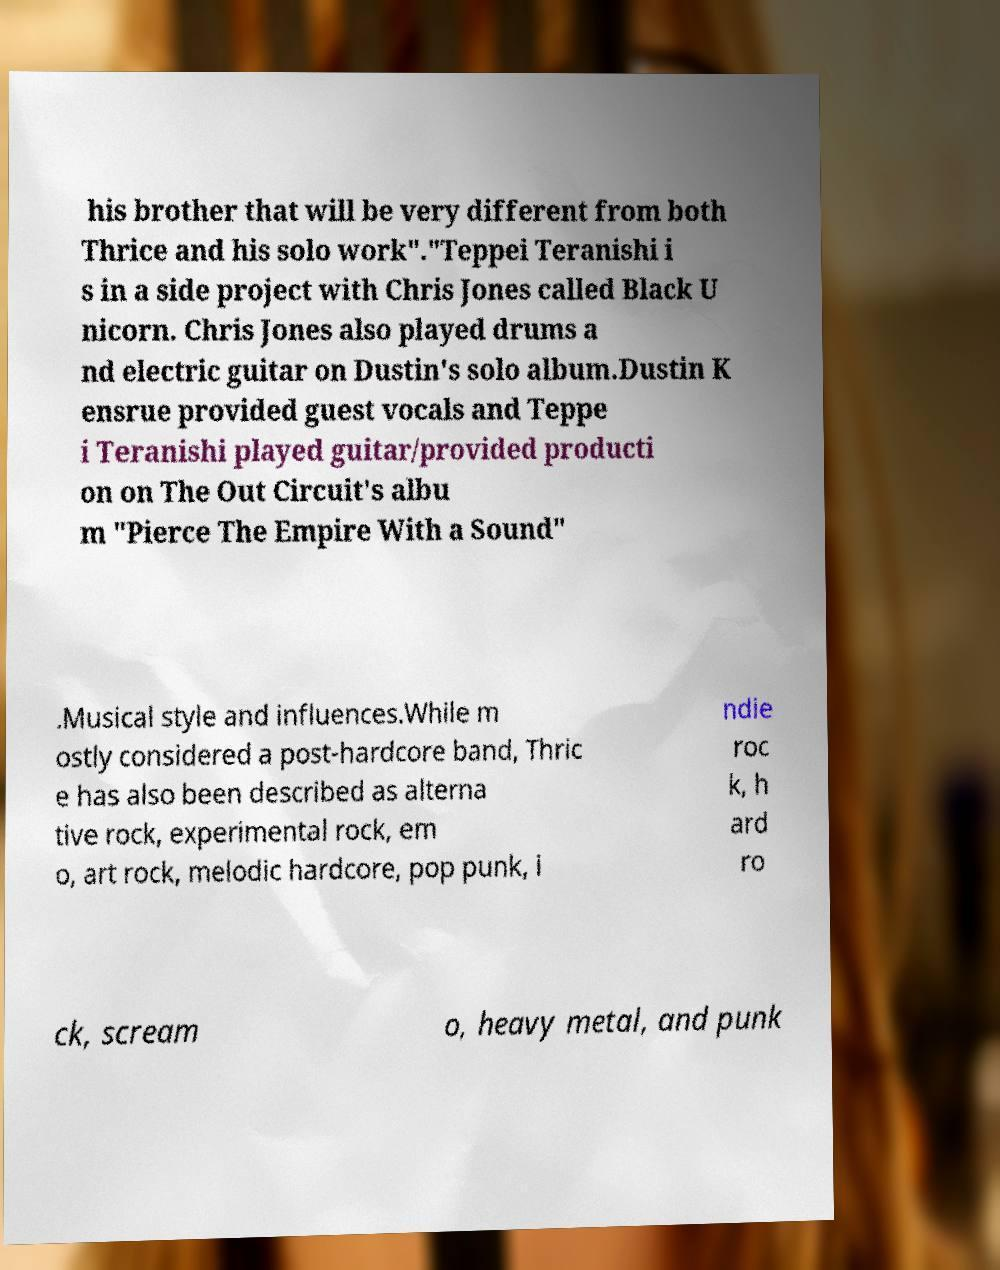Could you extract and type out the text from this image? his brother that will be very different from both Thrice and his solo work"."Teppei Teranishi i s in a side project with Chris Jones called Black U nicorn. Chris Jones also played drums a nd electric guitar on Dustin's solo album.Dustin K ensrue provided guest vocals and Teppe i Teranishi played guitar/provided producti on on The Out Circuit's albu m "Pierce The Empire With a Sound" .Musical style and influences.While m ostly considered a post-hardcore band, Thric e has also been described as alterna tive rock, experimental rock, em o, art rock, melodic hardcore, pop punk, i ndie roc k, h ard ro ck, scream o, heavy metal, and punk 